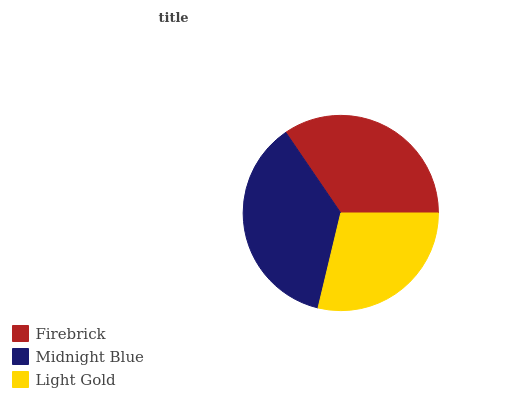Is Light Gold the minimum?
Answer yes or no. Yes. Is Midnight Blue the maximum?
Answer yes or no. Yes. Is Midnight Blue the minimum?
Answer yes or no. No. Is Light Gold the maximum?
Answer yes or no. No. Is Midnight Blue greater than Light Gold?
Answer yes or no. Yes. Is Light Gold less than Midnight Blue?
Answer yes or no. Yes. Is Light Gold greater than Midnight Blue?
Answer yes or no. No. Is Midnight Blue less than Light Gold?
Answer yes or no. No. Is Firebrick the high median?
Answer yes or no. Yes. Is Firebrick the low median?
Answer yes or no. Yes. Is Midnight Blue the high median?
Answer yes or no. No. Is Light Gold the low median?
Answer yes or no. No. 